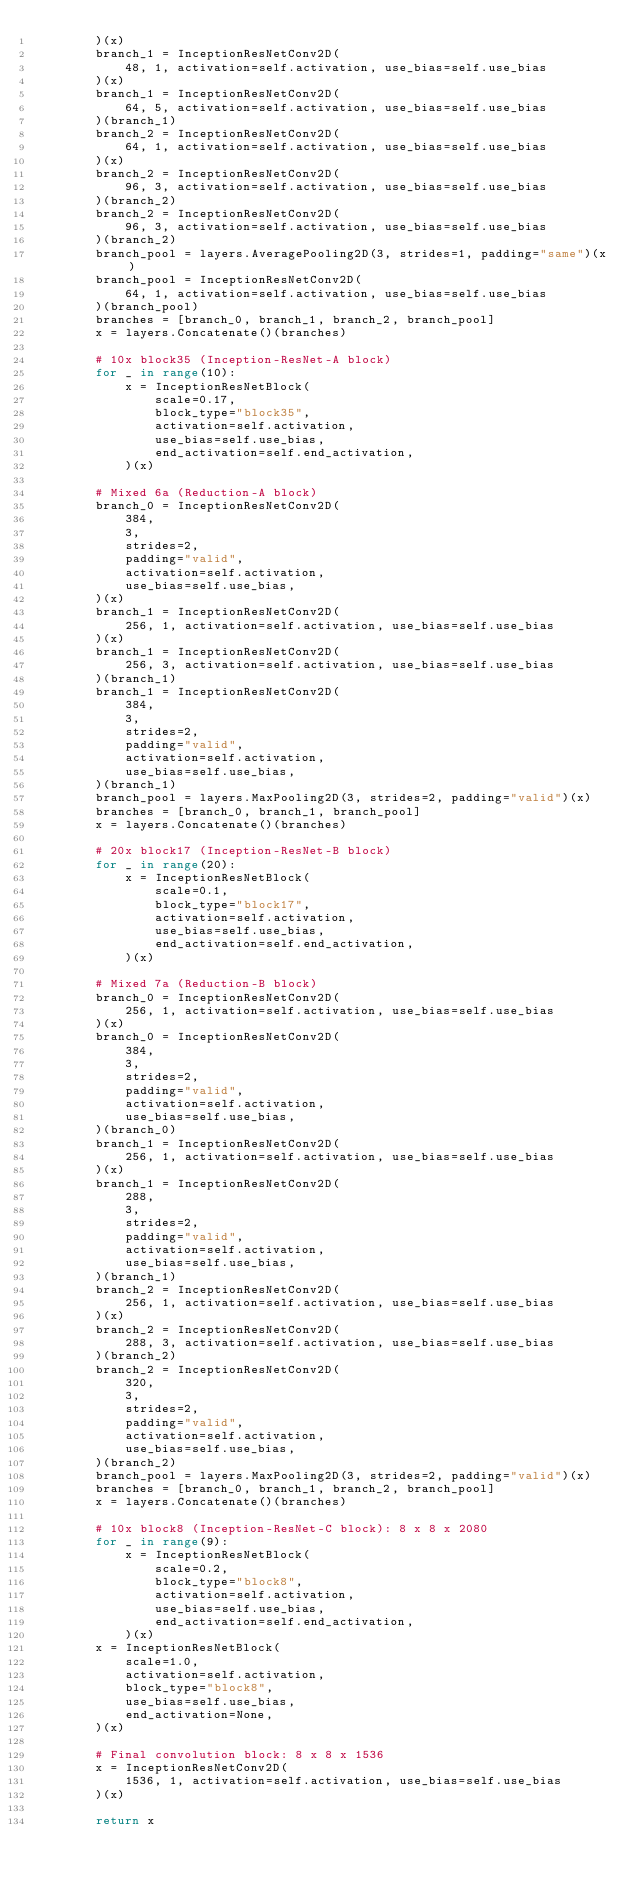<code> <loc_0><loc_0><loc_500><loc_500><_Python_>        )(x)
        branch_1 = InceptionResNetConv2D(
            48, 1, activation=self.activation, use_bias=self.use_bias
        )(x)
        branch_1 = InceptionResNetConv2D(
            64, 5, activation=self.activation, use_bias=self.use_bias
        )(branch_1)
        branch_2 = InceptionResNetConv2D(
            64, 1, activation=self.activation, use_bias=self.use_bias
        )(x)
        branch_2 = InceptionResNetConv2D(
            96, 3, activation=self.activation, use_bias=self.use_bias
        )(branch_2)
        branch_2 = InceptionResNetConv2D(
            96, 3, activation=self.activation, use_bias=self.use_bias
        )(branch_2)
        branch_pool = layers.AveragePooling2D(3, strides=1, padding="same")(x)
        branch_pool = InceptionResNetConv2D(
            64, 1, activation=self.activation, use_bias=self.use_bias
        )(branch_pool)
        branches = [branch_0, branch_1, branch_2, branch_pool]
        x = layers.Concatenate()(branches)

        # 10x block35 (Inception-ResNet-A block)
        for _ in range(10):
            x = InceptionResNetBlock(
                scale=0.17,
                block_type="block35",
                activation=self.activation,
                use_bias=self.use_bias,
                end_activation=self.end_activation,
            )(x)

        # Mixed 6a (Reduction-A block)
        branch_0 = InceptionResNetConv2D(
            384,
            3,
            strides=2,
            padding="valid",
            activation=self.activation,
            use_bias=self.use_bias,
        )(x)
        branch_1 = InceptionResNetConv2D(
            256, 1, activation=self.activation, use_bias=self.use_bias
        )(x)
        branch_1 = InceptionResNetConv2D(
            256, 3, activation=self.activation, use_bias=self.use_bias
        )(branch_1)
        branch_1 = InceptionResNetConv2D(
            384,
            3,
            strides=2,
            padding="valid",
            activation=self.activation,
            use_bias=self.use_bias,
        )(branch_1)
        branch_pool = layers.MaxPooling2D(3, strides=2, padding="valid")(x)
        branches = [branch_0, branch_1, branch_pool]
        x = layers.Concatenate()(branches)

        # 20x block17 (Inception-ResNet-B block)
        for _ in range(20):
            x = InceptionResNetBlock(
                scale=0.1,
                block_type="block17",
                activation=self.activation,
                use_bias=self.use_bias,
                end_activation=self.end_activation,
            )(x)

        # Mixed 7a (Reduction-B block)
        branch_0 = InceptionResNetConv2D(
            256, 1, activation=self.activation, use_bias=self.use_bias
        )(x)
        branch_0 = InceptionResNetConv2D(
            384,
            3,
            strides=2,
            padding="valid",
            activation=self.activation,
            use_bias=self.use_bias,
        )(branch_0)
        branch_1 = InceptionResNetConv2D(
            256, 1, activation=self.activation, use_bias=self.use_bias
        )(x)
        branch_1 = InceptionResNetConv2D(
            288,
            3,
            strides=2,
            padding="valid",
            activation=self.activation,
            use_bias=self.use_bias,
        )(branch_1)
        branch_2 = InceptionResNetConv2D(
            256, 1, activation=self.activation, use_bias=self.use_bias
        )(x)
        branch_2 = InceptionResNetConv2D(
            288, 3, activation=self.activation, use_bias=self.use_bias
        )(branch_2)
        branch_2 = InceptionResNetConv2D(
            320,
            3,
            strides=2,
            padding="valid",
            activation=self.activation,
            use_bias=self.use_bias,
        )(branch_2)
        branch_pool = layers.MaxPooling2D(3, strides=2, padding="valid")(x)
        branches = [branch_0, branch_1, branch_2, branch_pool]
        x = layers.Concatenate()(branches)

        # 10x block8 (Inception-ResNet-C block): 8 x 8 x 2080
        for _ in range(9):
            x = InceptionResNetBlock(
                scale=0.2,
                block_type="block8",
                activation=self.activation,
                use_bias=self.use_bias,
                end_activation=self.end_activation,
            )(x)
        x = InceptionResNetBlock(
            scale=1.0,
            activation=self.activation,
            block_type="block8",
            use_bias=self.use_bias,
            end_activation=None,
        )(x)

        # Final convolution block: 8 x 8 x 1536
        x = InceptionResNetConv2D(
            1536, 1, activation=self.activation, use_bias=self.use_bias
        )(x)

        return x</code> 